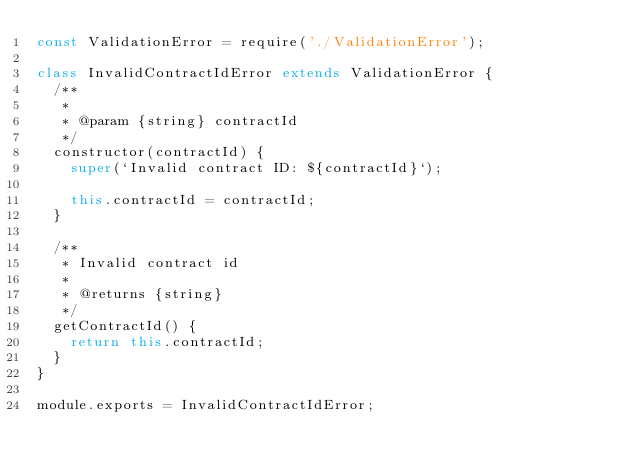Convert code to text. <code><loc_0><loc_0><loc_500><loc_500><_JavaScript_>const ValidationError = require('./ValidationError');

class InvalidContractIdError extends ValidationError {
  /**
   *
   * @param {string} contractId
   */
  constructor(contractId) {
    super(`Invalid contract ID: ${contractId}`);

    this.contractId = contractId;
  }

  /**
   * Invalid contract id
   *
   * @returns {string}
   */
  getContractId() {
    return this.contractId;
  }
}

module.exports = InvalidContractIdError;
</code> 